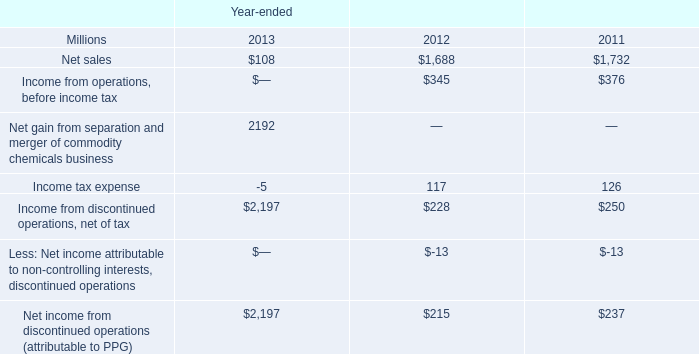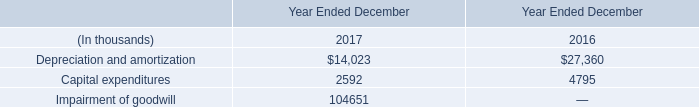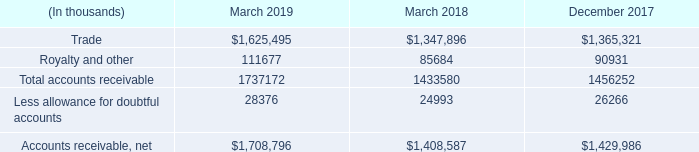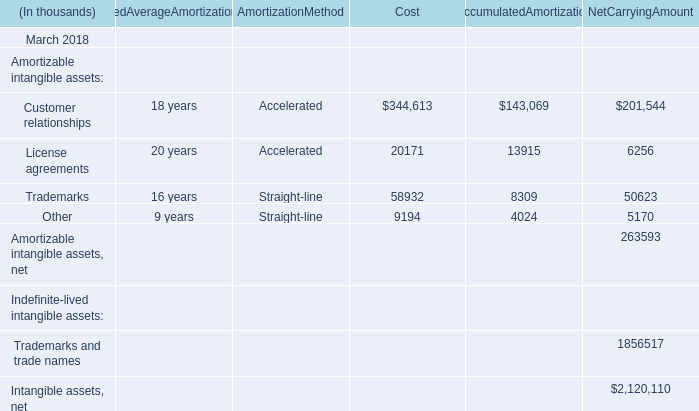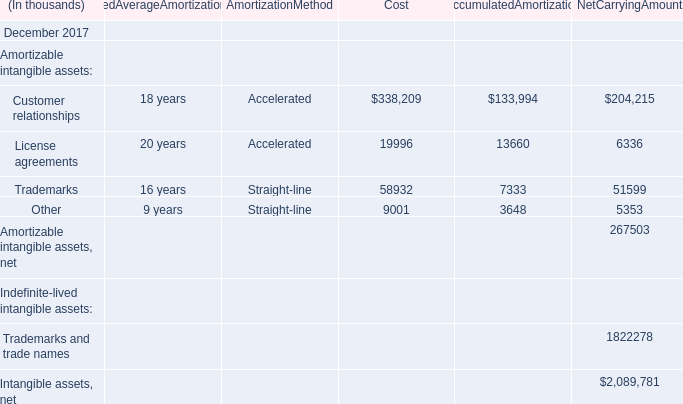What is the ratio of all Cost that are in the range of 20000 and 400000 to the sum of Cost in 2017? 
Computations: ((338209 + 58932) / (((338209 + 58932) + 19996) + 9001))
Answer: 0.93195. 